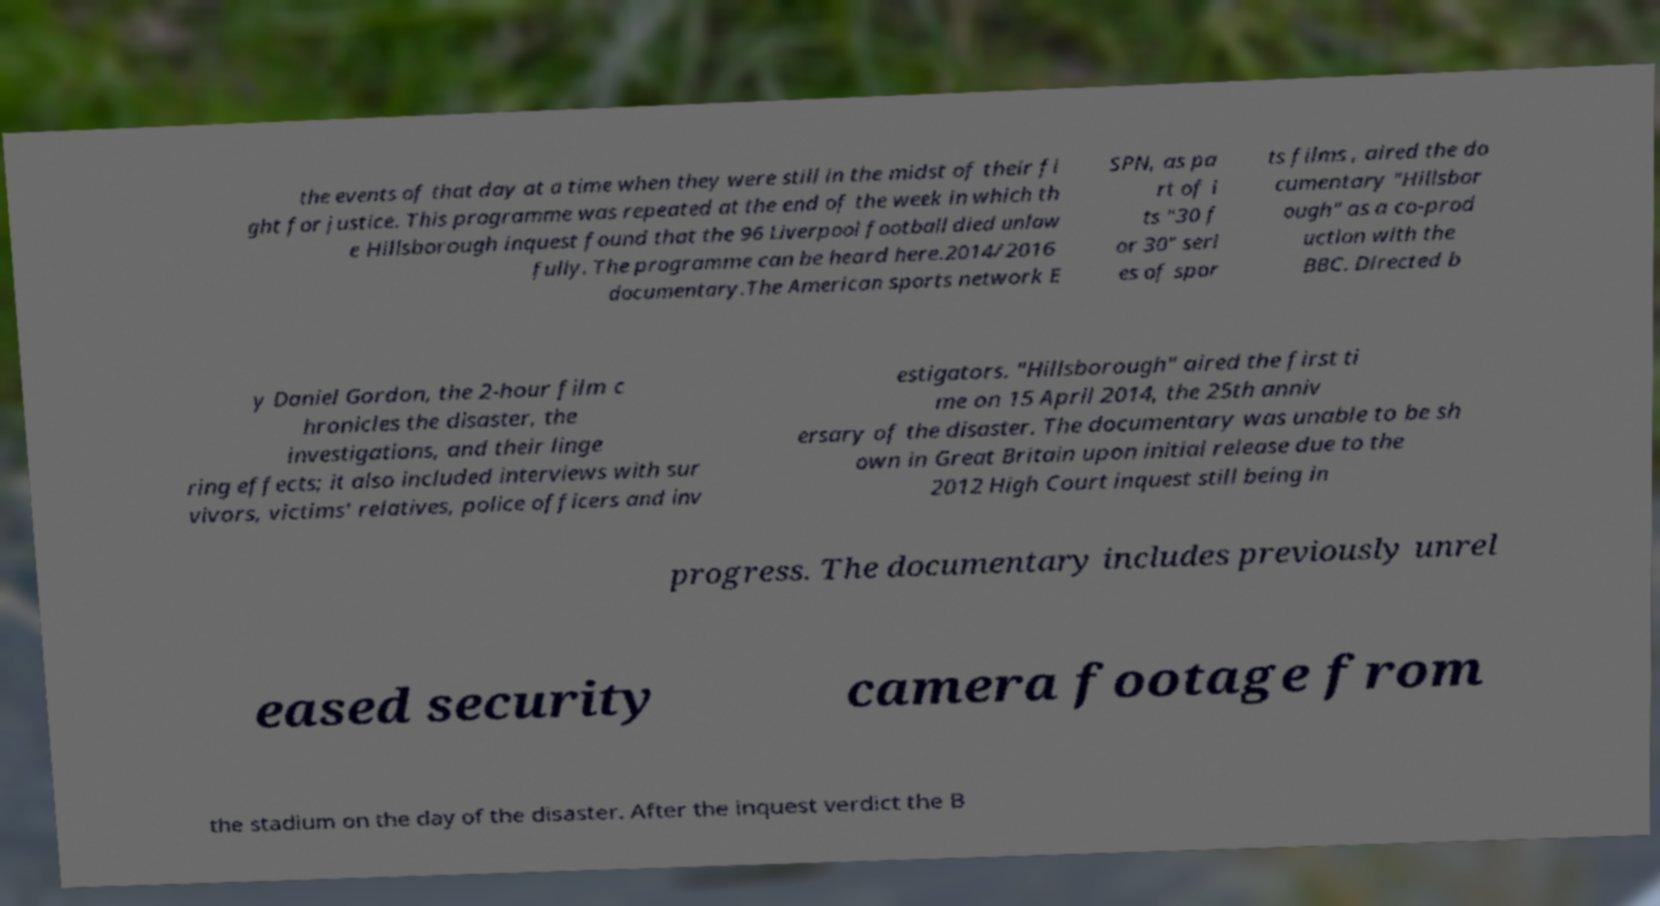Please identify and transcribe the text found in this image. the events of that day at a time when they were still in the midst of their fi ght for justice. This programme was repeated at the end of the week in which th e Hillsborough inquest found that the 96 Liverpool football died unlaw fully. The programme can be heard here.2014/2016 documentary.The American sports network E SPN, as pa rt of i ts "30 f or 30" seri es of spor ts films , aired the do cumentary "Hillsbor ough" as a co-prod uction with the BBC. Directed b y Daniel Gordon, the 2-hour film c hronicles the disaster, the investigations, and their linge ring effects; it also included interviews with sur vivors, victims' relatives, police officers and inv estigators. "Hillsborough" aired the first ti me on 15 April 2014, the 25th anniv ersary of the disaster. The documentary was unable to be sh own in Great Britain upon initial release due to the 2012 High Court inquest still being in progress. The documentary includes previously unrel eased security camera footage from the stadium on the day of the disaster. After the inquest verdict the B 